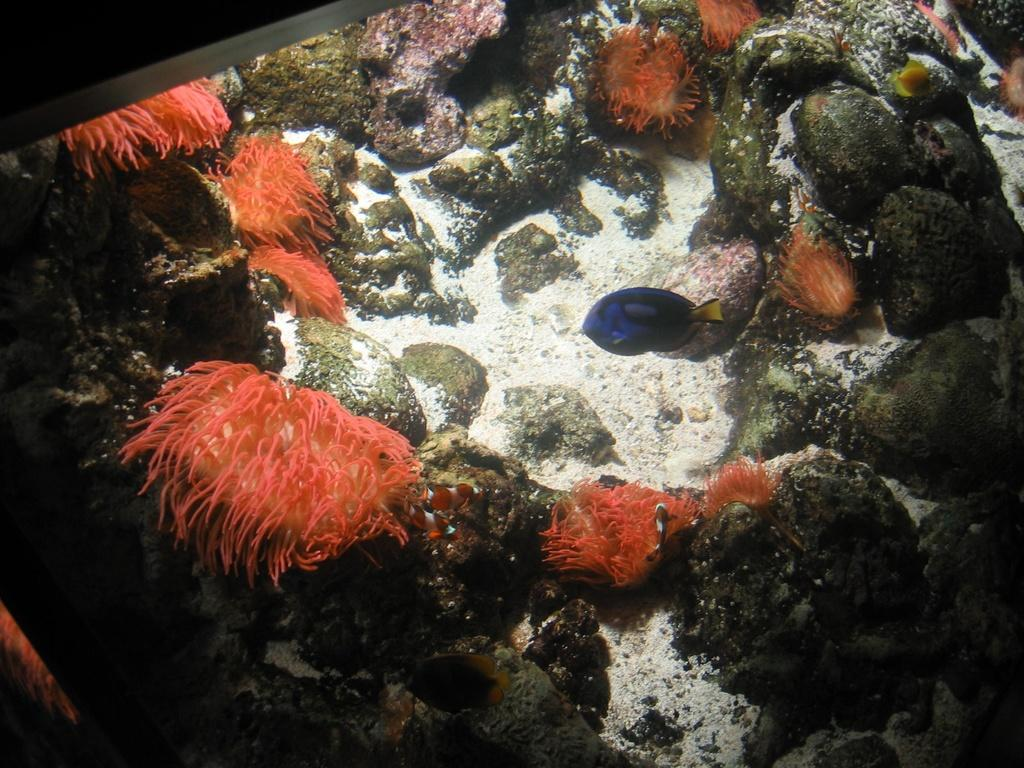What type of environment is shown in the image? The image depicts an underwater environment. What type of animal can be seen in the image? There is a fish in the image. What resembles a plant in the image? There is an orange color object that resembles a plant in the image. What type of inanimate objects are present in the image? Stones are present in the image. What type of drug can be seen in the image? There is no drug present in the image; it depicts an underwater environment with a fish, an orange color object resembling a plant, and stones. What type of straw is visible in the image? There is no straw present in the image. 